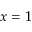<formula> <loc_0><loc_0><loc_500><loc_500>x = 1</formula> 